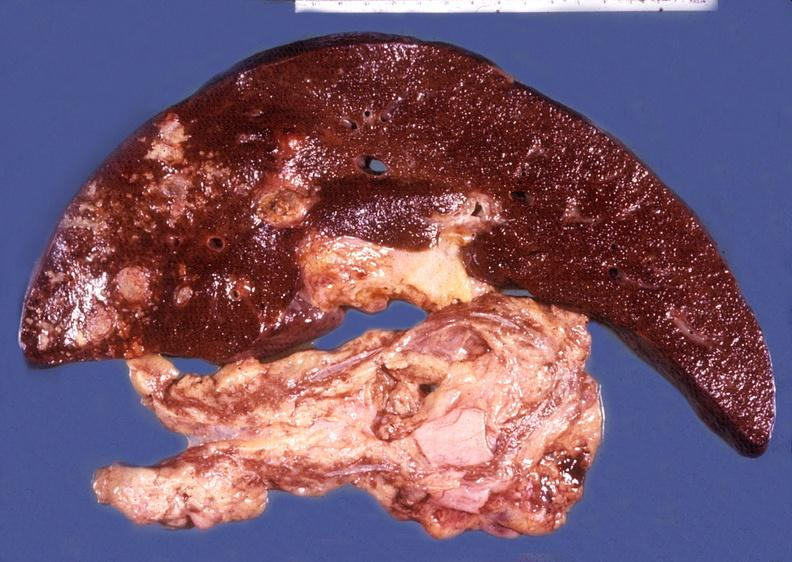does notochord show liver and pancreas, hemochromatosis and liver hepatoma?
Answer the question using a single word or phrase. No 